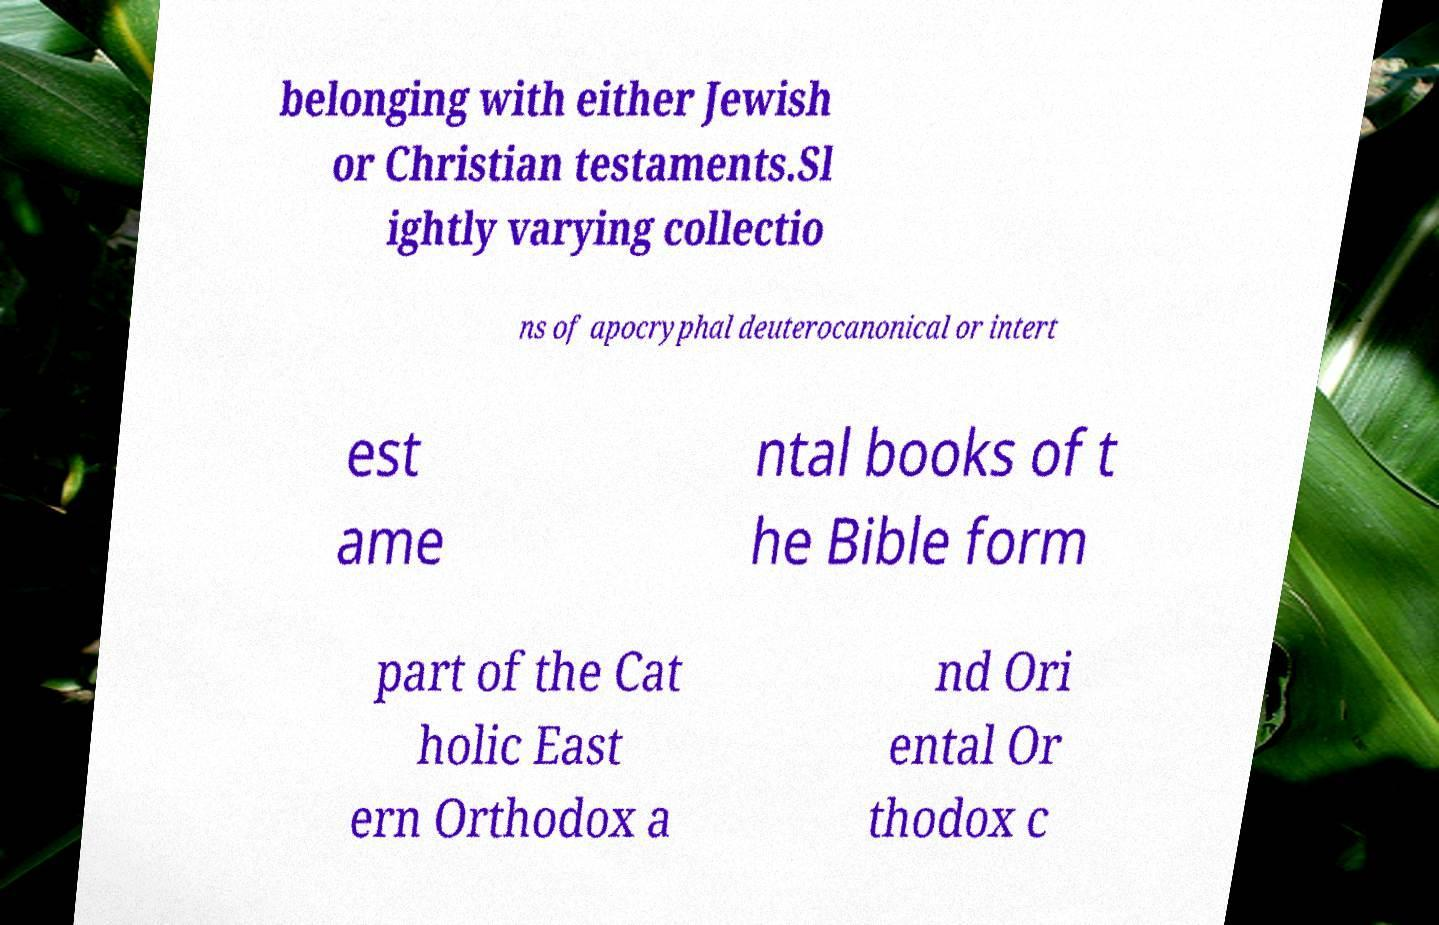Can you accurately transcribe the text from the provided image for me? belonging with either Jewish or Christian testaments.Sl ightly varying collectio ns of apocryphal deuterocanonical or intert est ame ntal books of t he Bible form part of the Cat holic East ern Orthodox a nd Ori ental Or thodox c 